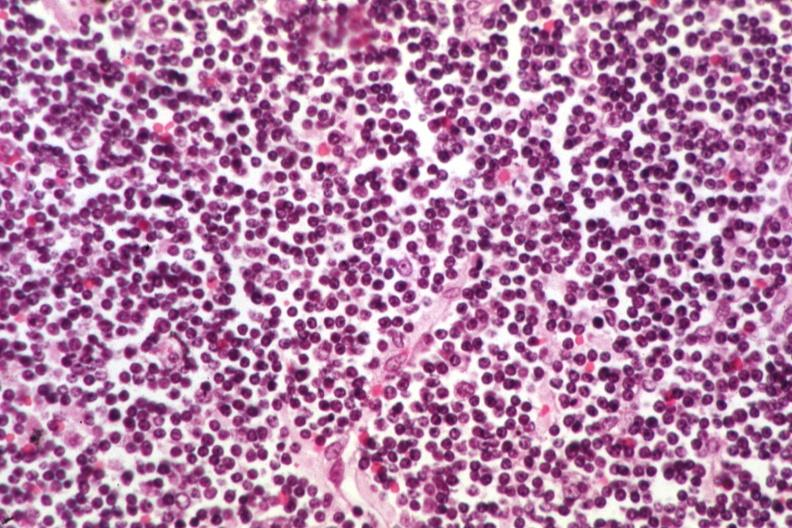s intramural one lesion present?
Answer the question using a single word or phrase. No 